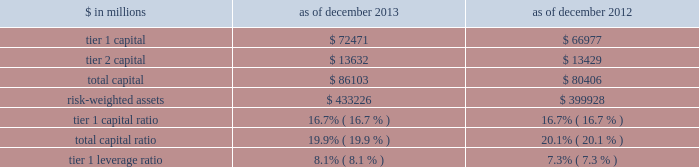Notes to consolidated financial statements the table below presents information regarding group inc . 2019s regulatory capital ratios and tier 1 leverage ratio under basel i , as implemented by the federal reserve board .
The information as of december 2013 reflects the revised market risk regulatory capital requirements .
These changes resulted in increased regulatory capital requirements for market risk .
The information as of december 2012 is prior to the implementation of these revised market risk regulatory capital requirements. .
Revised capital framework the u.s .
Federal bank regulatory agencies ( agencies ) have approved revised risk-based capital and leverage ratio regulations establishing a new comprehensive capital framework for u.s .
Banking organizations ( revised capital framework ) .
These regulations are largely based on the basel committee 2019s december 2010 final capital framework for strengthening international capital standards ( basel iii ) and also implement certain provisions of the dodd-frank act .
Under the revised capital framework , group inc .
Is an 201cadvanced approach 201d banking organization .
Below are the aspects of the rules that are most relevant to the firm , as an advanced approach banking organization .
Definition of capital and capital ratios .
The revised capital framework introduced changes to the definition of regulatory capital , which , subject to transitional provisions , became effective across the firm 2019s regulatory capital and leverage ratios on january 1 , 2014 .
These changes include the introduction of a new capital measure called common equity tier 1 ( cet1 ) , and the related regulatory capital ratio of cet1 to rwas ( cet1 ratio ) .
In addition , the definition of tier 1 capital has been narrowed to include only cet1 and instruments such as perpetual non- cumulative preferred stock , which meet certain criteria .
Certain aspects of the revised requirements phase in over time .
These include increases in the minimum capital ratio requirements and the introduction of new capital buffers and certain deductions from regulatory capital ( such as investments in nonconsolidated financial institutions ) .
In addition , junior subordinated debt issued to trusts is being phased out of regulatory capital .
The minimum cet1 ratio is 4.0% ( 4.0 % ) as of january 1 , 2014 and will increase to 4.5% ( 4.5 % ) on january 1 , 2015 .
The minimum tier 1 capital ratio increased from 4.0% ( 4.0 % ) to 5.5% ( 5.5 % ) on january 1 , 2014 and will increase to 6.0% ( 6.0 % ) beginning january 1 , 2015 .
The minimum total capital ratio remains unchanged at 8.0% ( 8.0 % ) .
These minimum ratios will be supplemented by a new capital conservation buffer that phases in , beginning january 1 , 2016 , in increments of 0.625% ( 0.625 % ) per year until it reaches 2.5% ( 2.5 % ) on january 1 , 2019 .
The revised capital framework also introduces a new counter-cyclical capital buffer , to be imposed in the event that national supervisors deem it necessary in order to counteract excessive credit growth .
Risk-weighted assets .
In february 2014 , the federal reserve board informed us that we have completed a satisfactory 201cparallel run , 201d as required of advanced approach banking organizations under the revised capital framework , and therefore changes to rwas will take effect beginning with the second quarter of 2014 .
Accordingly , the calculation of rwas in future quarters will be based on the following methodologies : 2030 during the first quarter of 2014 2014 the basel i risk-based capital framework adjusted for certain items related to existing capital deductions and the phase-in of new capital deductions ( basel i adjusted ) ; 2030 during the remaining quarters of 2014 2014 the higher of rwas computed under the basel iii advanced approach or the basel i adjusted calculation ; and 2030 beginning in the first quarter of 2015 2014 the higher of rwas computed under the basel iii advanced or standardized approach .
Goldman sachs 2013 annual report 191 .
What was the percentage change in tier 2 capital between 2012 and 2013? 
Computations: ((13632 - 13429) / 13429)
Answer: 0.01512. 